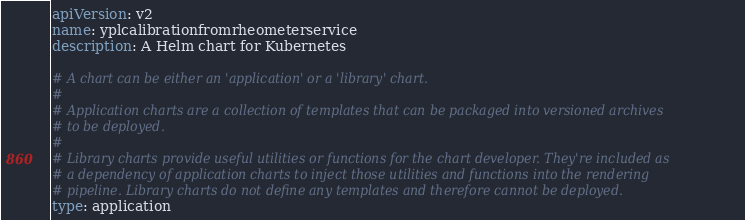Convert code to text. <code><loc_0><loc_0><loc_500><loc_500><_YAML_>apiVersion: v2
name: yplcalibrationfromrheometerservice
description: A Helm chart for Kubernetes

# A chart can be either an 'application' or a 'library' chart.
#
# Application charts are a collection of templates that can be packaged into versioned archives
# to be deployed.
#
# Library charts provide useful utilities or functions for the chart developer. They're included as
# a dependency of application charts to inject those utilities and functions into the rendering
# pipeline. Library charts do not define any templates and therefore cannot be deployed.
type: application
</code> 